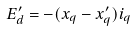Convert formula to latex. <formula><loc_0><loc_0><loc_500><loc_500>E ^ { \prime } _ { d } = - ( x _ { q } - x ^ { \prime } _ { q } ) i _ { q }</formula> 